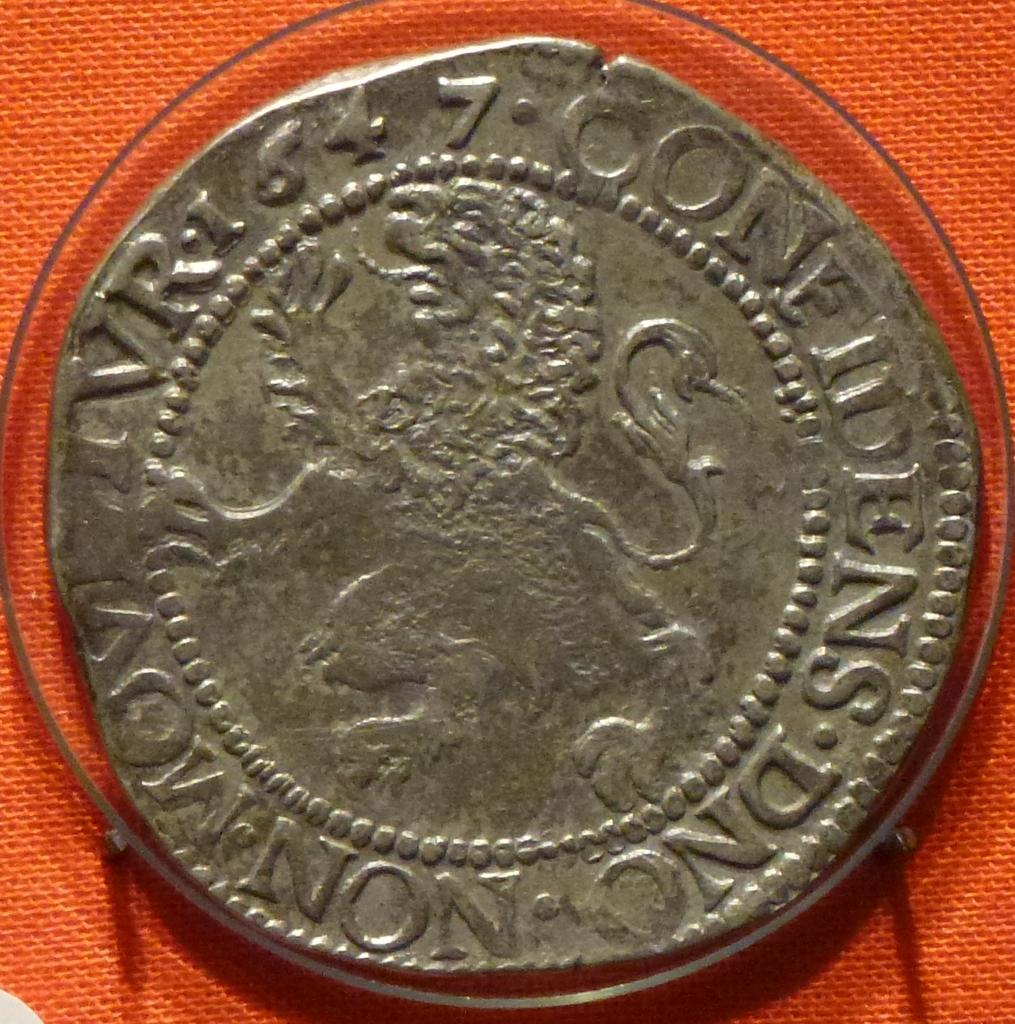<image>
Relay a brief, clear account of the picture shown. An old silver coin on top of an orange cloth and with the numbers 64 7 on it. 